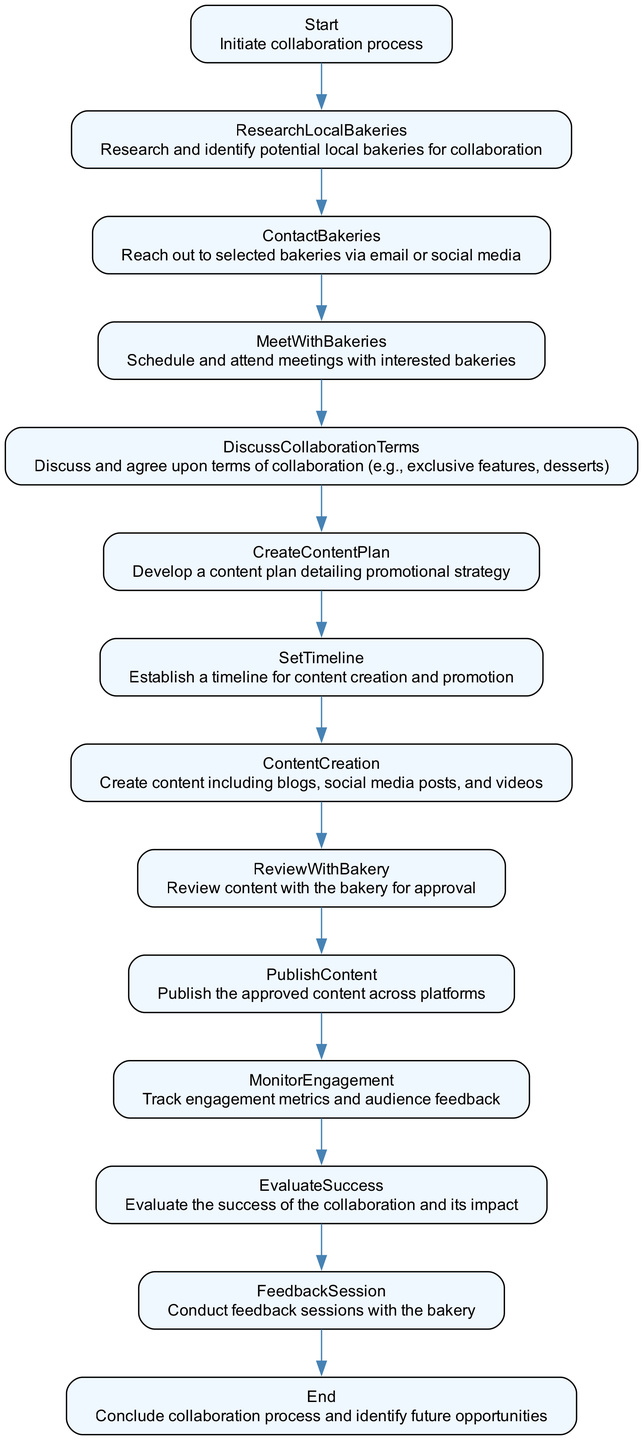What is the first step in the collaboration process? The diagram indicates that the first step is "Initiate collaboration process." This is the starting point from which all subsequent actions flow.
Answer: Initiate collaboration process How many nodes are present in the flowchart? By counting the individual steps represented as nodes in the diagram, we find there are a total of 14 distinct nodes.
Answer: 14 What is the last action in the collaboration process? The final step, as illustrated in the diagram, is "Conclude collaboration process and identify future opportunities." This indicates the end point of the process.
Answer: Conclude collaboration process and identify future opportunities Which step follows the "Review with Bakery" node? The diagram shows that the node "Publish Content" directly follows the "Review with Bakery" node, indicating the order of operations.
Answer: Publish Content What terms are discussed after meeting with the bakeries? The flowchart specifies that the next action after meeting is to "Discuss and agree upon terms of collaboration (e.g., exclusive features, desserts)," which describes what is negotiated at this stage.
Answer: Discuss and agree upon terms of collaboration How does the collaboration process evaluate its success? The process evaluates success by "Evaluate the success of the collaboration and its impact," which is a critical step in understanding the effectiveness of the collaboration.
Answer: Evaluate the success of the collaboration and its impact What is required before publishing content? The flowchart illustrates that "Review content with the bakery for approval" is a prerequisite to the "Publish Content" step, ensuring quality and agreement on the content.
Answer: Review content with the bakery for approval How is the content creation planned? The diagram indicates that a "Create Content Plan" step is established after discussing terms, detailing how the content will be crafted and promoted.
Answer: Create Content Plan 